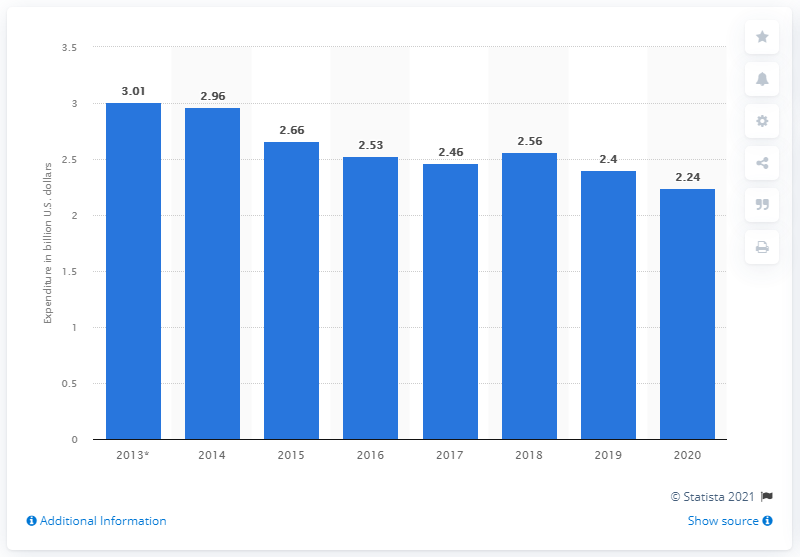Highlight a few significant elements in this photo. Ecuador spent 2.24 billion dollars on its military in 2020. 